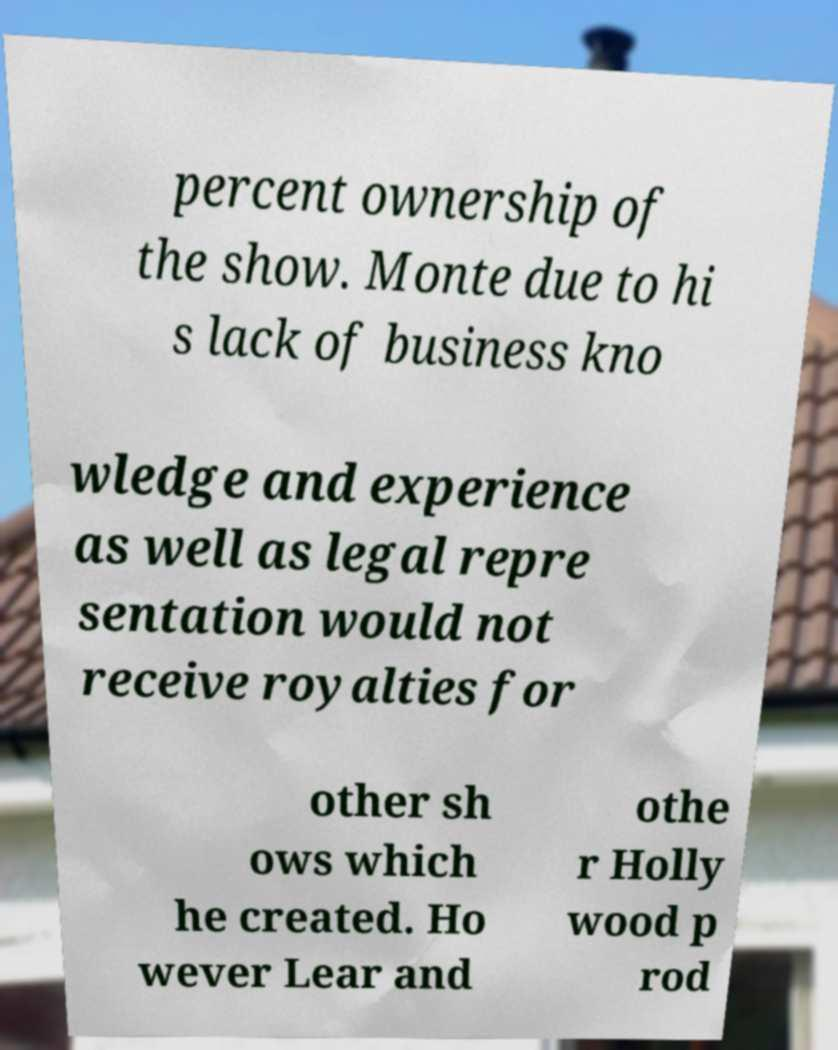There's text embedded in this image that I need extracted. Can you transcribe it verbatim? percent ownership of the show. Monte due to hi s lack of business kno wledge and experience as well as legal repre sentation would not receive royalties for other sh ows which he created. Ho wever Lear and othe r Holly wood p rod 